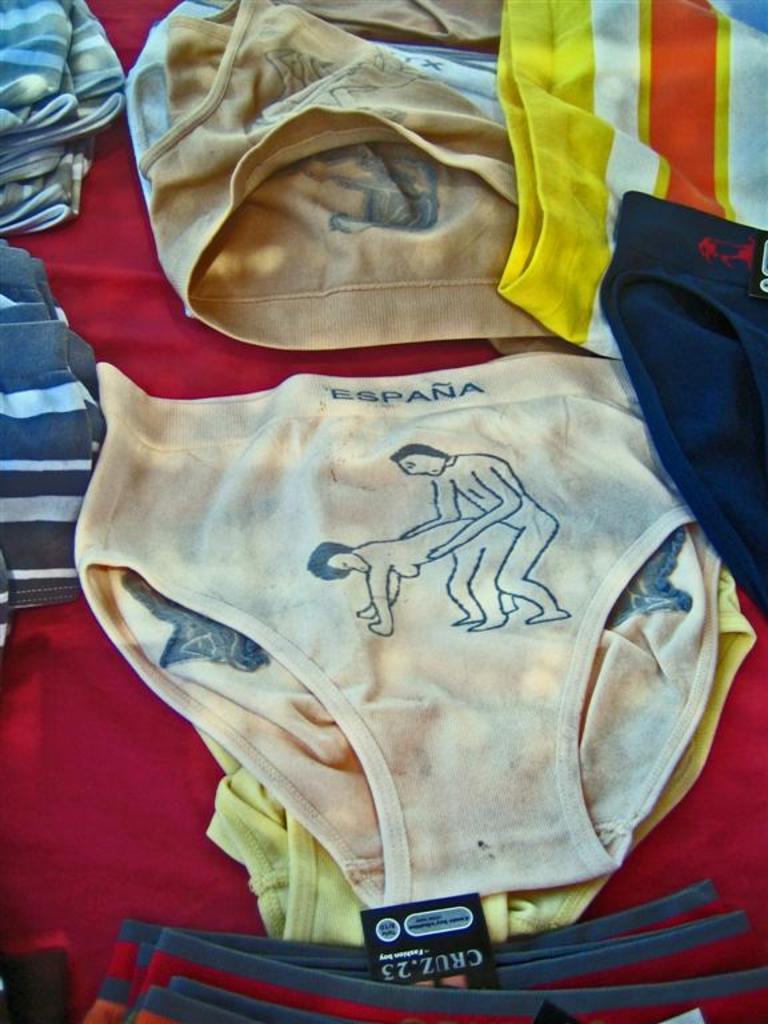What country is on the underwear?
Provide a succinct answer. Espana. What color is the country wrote on the underwear?
Ensure brevity in your answer.  Blue. 